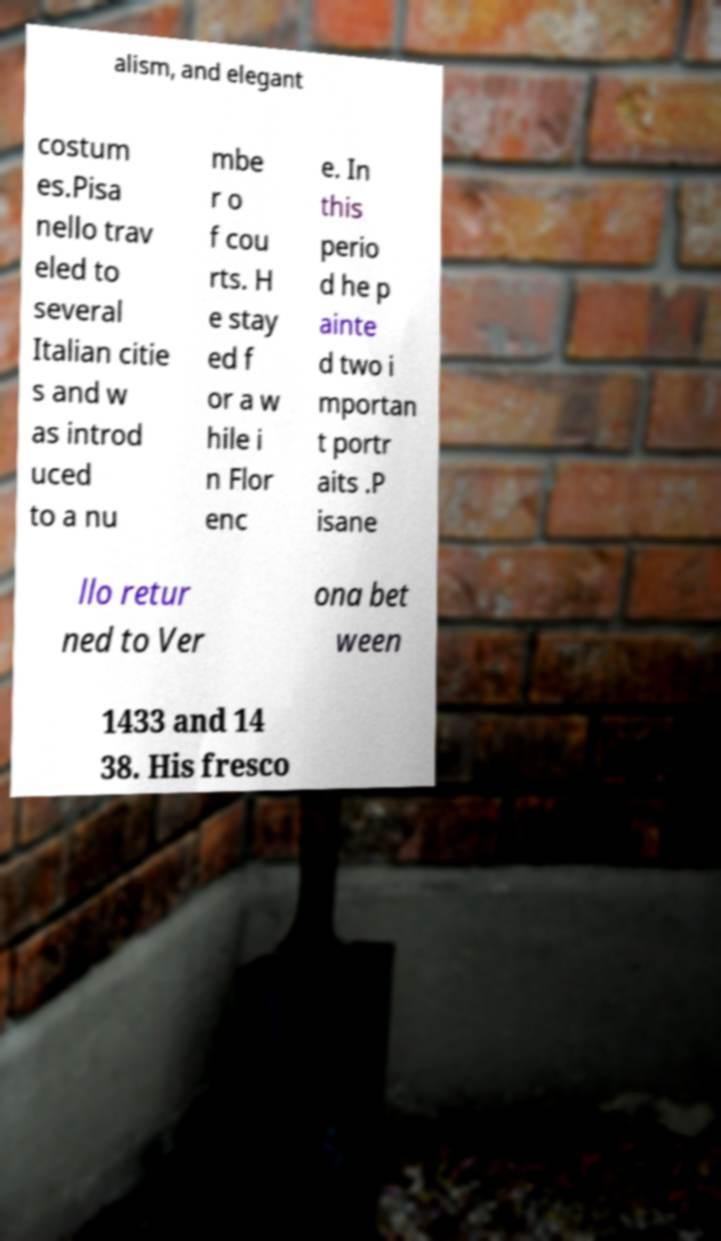Could you assist in decoding the text presented in this image and type it out clearly? alism, and elegant costum es.Pisa nello trav eled to several Italian citie s and w as introd uced to a nu mbe r o f cou rts. H e stay ed f or a w hile i n Flor enc e. In this perio d he p ainte d two i mportan t portr aits .P isane llo retur ned to Ver ona bet ween 1433 and 14 38. His fresco 